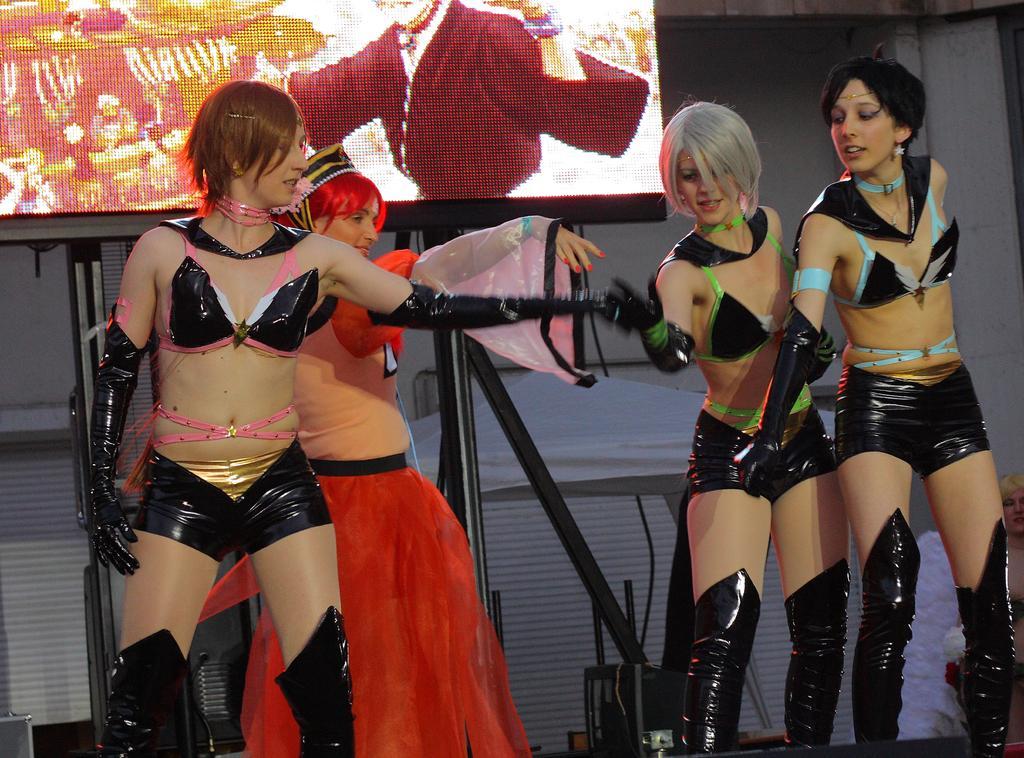Could you give a brief overview of what you see in this image? In the foreground I can see four women's on the stage. In the background I can see a stand, screen and a wall. This image is taken may be on the stage. 